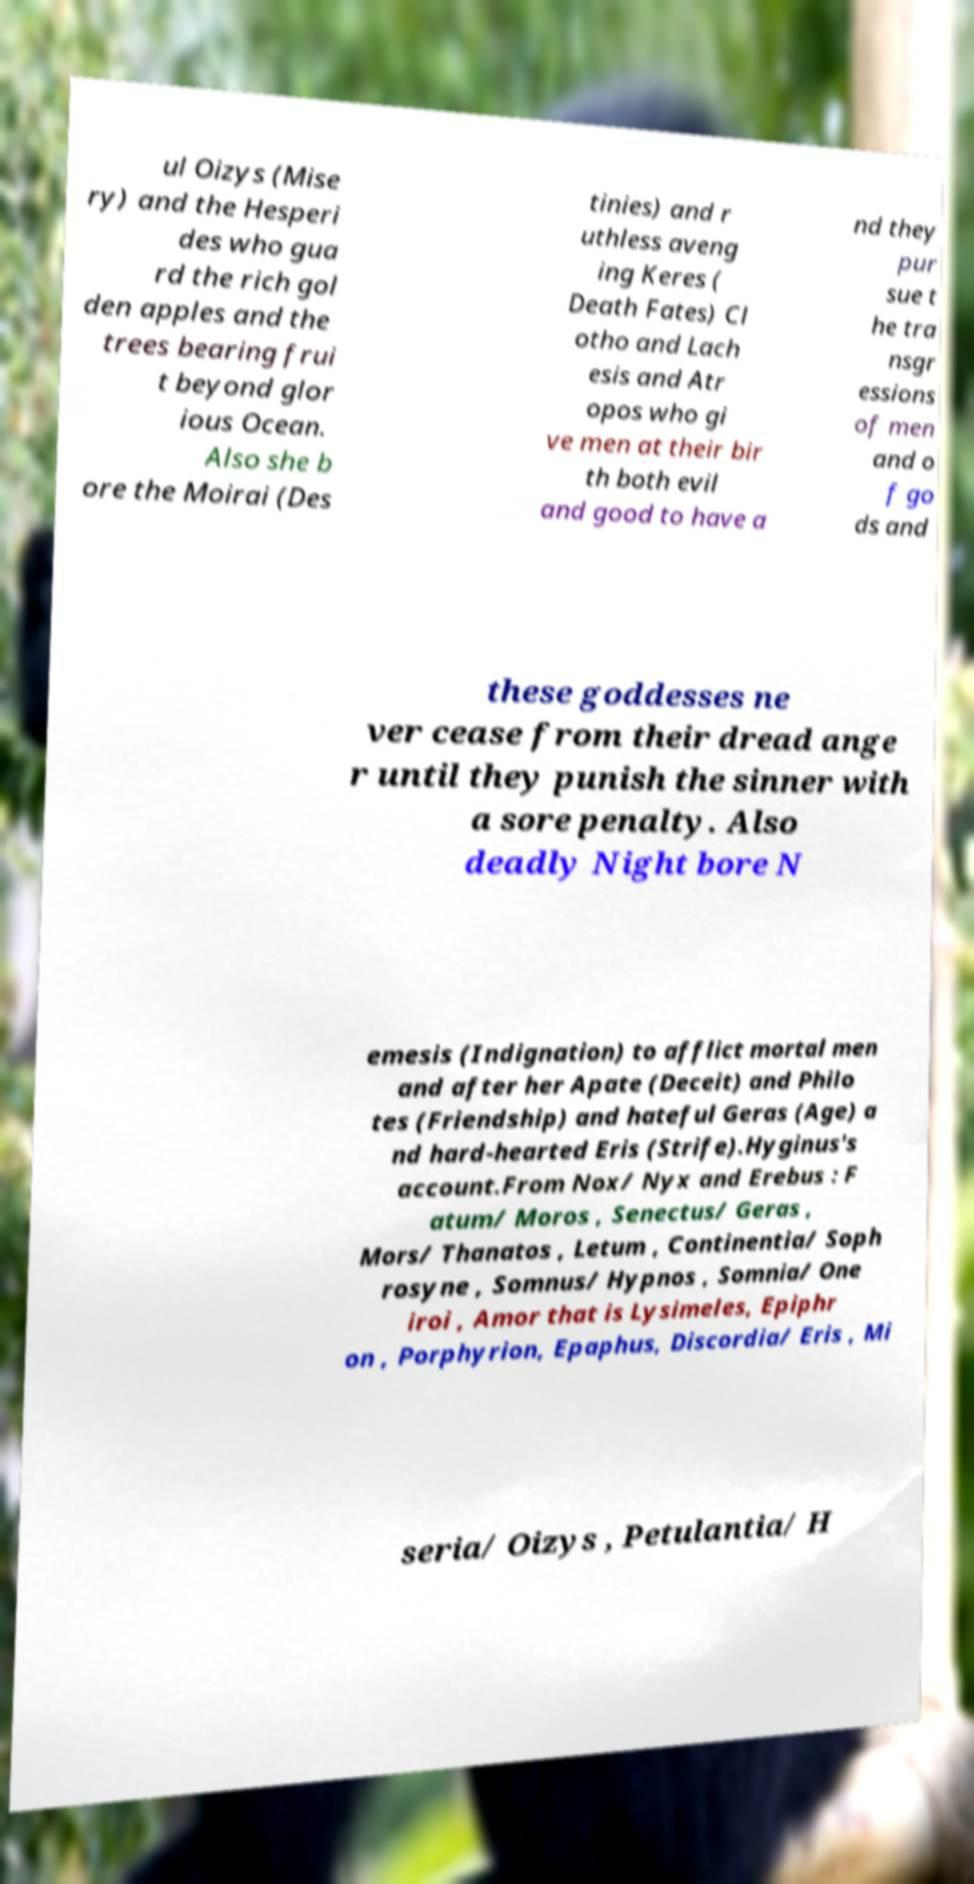Could you extract and type out the text from this image? ul Oizys (Mise ry) and the Hesperi des who gua rd the rich gol den apples and the trees bearing frui t beyond glor ious Ocean. Also she b ore the Moirai (Des tinies) and r uthless aveng ing Keres ( Death Fates) Cl otho and Lach esis and Atr opos who gi ve men at their bir th both evil and good to have a nd they pur sue t he tra nsgr essions of men and o f go ds and these goddesses ne ver cease from their dread ange r until they punish the sinner with a sore penalty. Also deadly Night bore N emesis (Indignation) to afflict mortal men and after her Apate (Deceit) and Philo tes (Friendship) and hateful Geras (Age) a nd hard-hearted Eris (Strife).Hyginus's account.From Nox/ Nyx and Erebus : F atum/ Moros , Senectus/ Geras , Mors/ Thanatos , Letum , Continentia/ Soph rosyne , Somnus/ Hypnos , Somnia/ One iroi , Amor that is Lysimeles, Epiphr on , Porphyrion, Epaphus, Discordia/ Eris , Mi seria/ Oizys , Petulantia/ H 